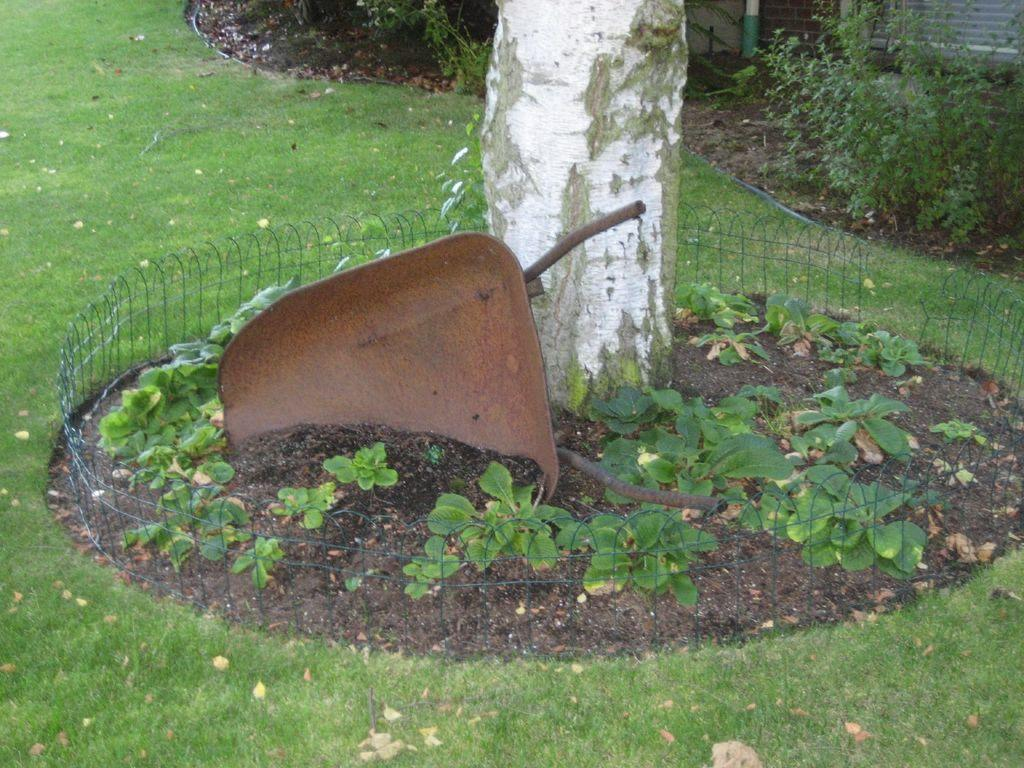What type of vegetation can be seen in the image? There is grass in the image. What structure is present in the image? There is a fence in the image. Can you describe the tree in the image? There is a tree stem in the image. What other types of vegetation are present in the image? There are plants in the image. What type of robin can be seen perched on the fence in the image? There is no robin present in the image; only grass, a fence, a tree stem, and plants are visible. Can you tell me what color the bottle is in the image? There is no bottle present in the image. 